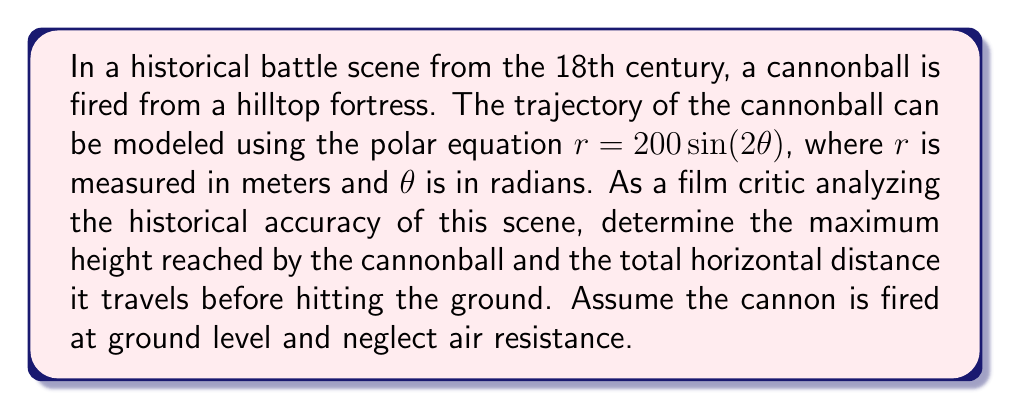What is the answer to this math problem? To solve this problem, we'll follow these steps:

1) The polar equation $r = 200\sin(2\theta)$ represents a rose curve with two petals.

2) The maximum height occurs when $\theta = \frac{\pi}{4}$ (45°), which is the top of the first petal.

3) To find the maximum height:
   At $\theta = \frac{\pi}{4}$, $r = 200\sin(2\cdot\frac{\pi}{4}) = 200\sin(\frac{\pi}{2}) = 200$ meters
   
   The vertical component is:
   $$y = r\sin(\theta) = 200\sin(\frac{\pi}{4}) = 200 \cdot \frac{\sqrt{2}}{2} \approx 141.4$$ meters

4) The horizontal distance is twice the horizontal component at $\theta = \frac{\pi}{4}$:
   $$x = 2r\cos(\theta) = 2 \cdot 200\cos(\frac{\pi}{4}) = 400 \cdot \frac{\sqrt{2}}{2} \approx 282.8$$ meters

5) To visualize the trajectory:

[asy]
import graph;
size(200);
real f(real t) {return 200*sin(2*t);}
draw(polargraph(f,0,pi/2),blue);
draw((0,0)--(200*cos(pi/4),200*sin(pi/4)),red,Arrow);
draw((0,0)--(282.8,0),green,Arrow);
draw((282.8,0)--(282.8,141.4),dashed);
label("Max Height",(282.8,70),E);
label("Horizontal Distance",(141.4,0),S);
[/asy]

This diagram shows half of the trajectory, which is symmetric. The red arrow indicates the maximum height, and the green arrow shows the total horizontal distance.
Answer: The maximum height reached by the cannonball is approximately 141.4 meters, and the total horizontal distance traveled is approximately 282.8 meters. 